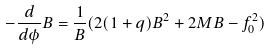Convert formula to latex. <formula><loc_0><loc_0><loc_500><loc_500>- \frac { d } { d \phi } B = \frac { 1 } { B } ( 2 ( 1 + q ) B ^ { 2 } + 2 M B - f _ { 0 } ^ { 2 } )</formula> 